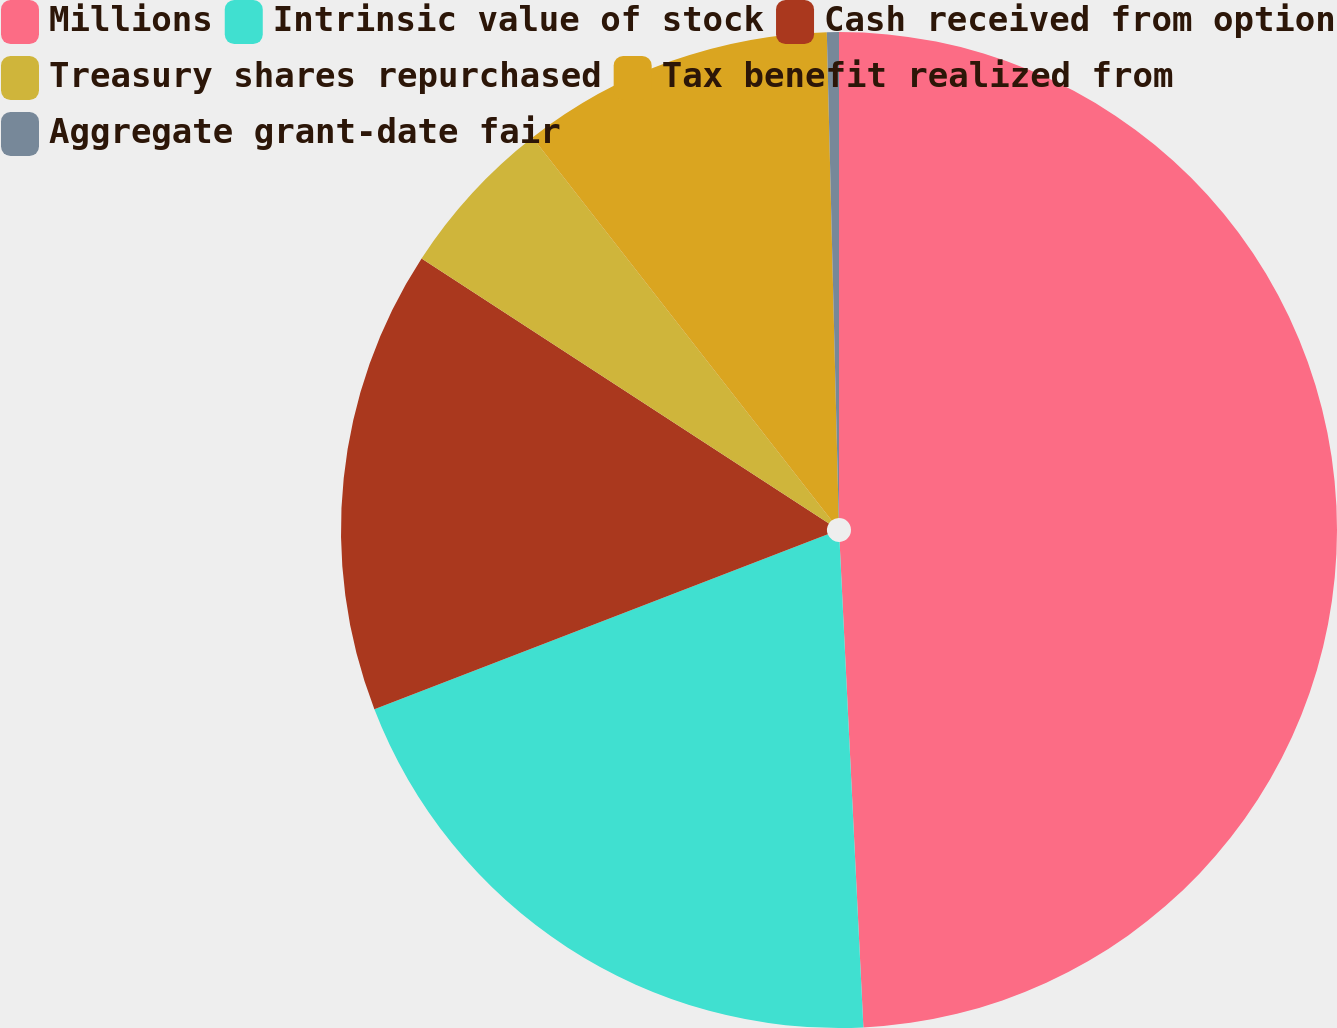Convert chart. <chart><loc_0><loc_0><loc_500><loc_500><pie_chart><fcel>Millions<fcel>Intrinsic value of stock<fcel>Cash received from option<fcel>Treasury shares repurchased<fcel>Tax benefit realized from<fcel>Aggregate grant-date fair<nl><fcel>49.22%<fcel>19.92%<fcel>15.04%<fcel>5.27%<fcel>10.16%<fcel>0.39%<nl></chart> 